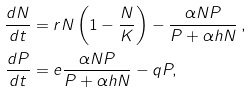<formula> <loc_0><loc_0><loc_500><loc_500>\frac { d N } { d t } & = r N \left ( 1 - \frac { N } { K } \right ) - \frac { \alpha N P } { P + \alpha h N } \, , \\ \frac { d P } { d t } & = e \frac { \alpha N P } { P + \alpha h N } - q P ,</formula> 